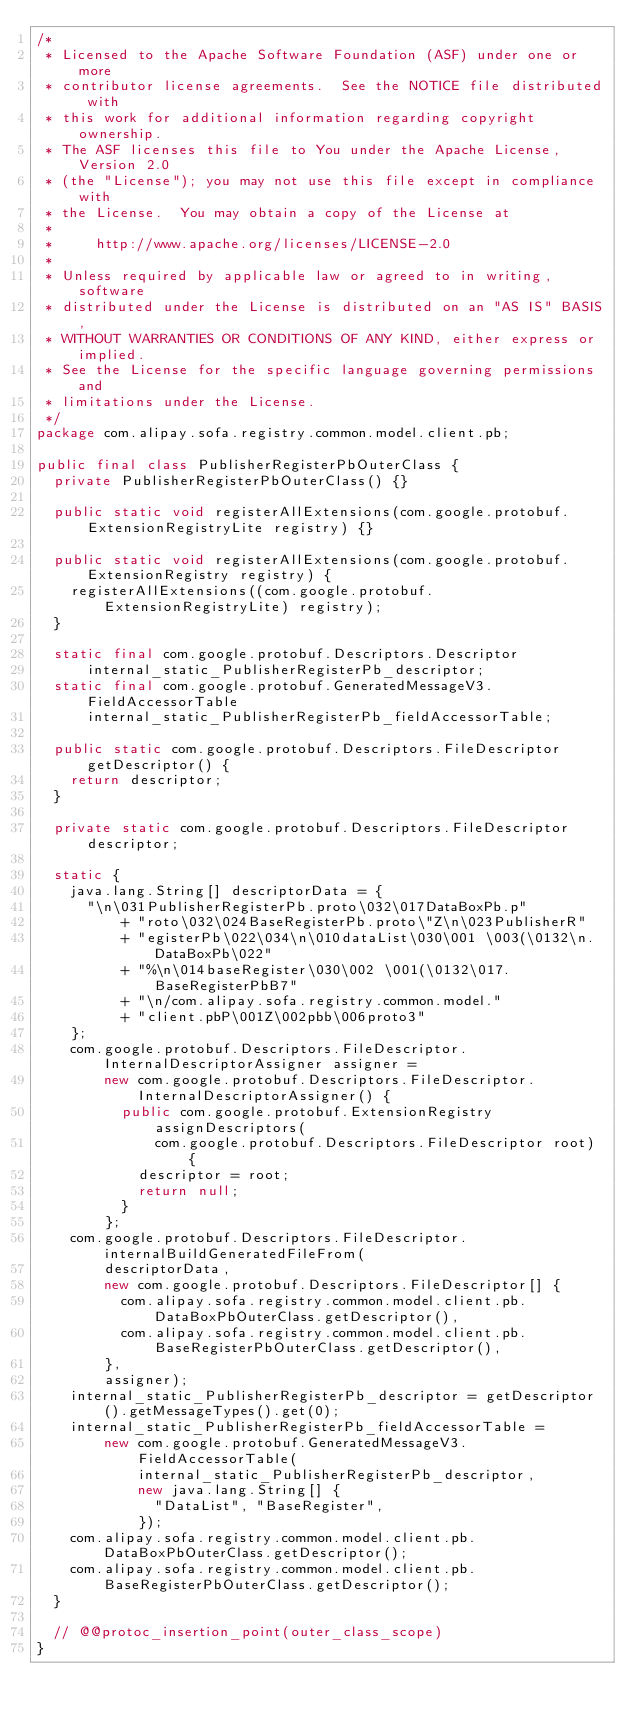<code> <loc_0><loc_0><loc_500><loc_500><_Java_>/*
 * Licensed to the Apache Software Foundation (ASF) under one or more
 * contributor license agreements.  See the NOTICE file distributed with
 * this work for additional information regarding copyright ownership.
 * The ASF licenses this file to You under the Apache License, Version 2.0
 * (the "License"); you may not use this file except in compliance with
 * the License.  You may obtain a copy of the License at
 *
 *     http://www.apache.org/licenses/LICENSE-2.0
 *
 * Unless required by applicable law or agreed to in writing, software
 * distributed under the License is distributed on an "AS IS" BASIS,
 * WITHOUT WARRANTIES OR CONDITIONS OF ANY KIND, either express or implied.
 * See the License for the specific language governing permissions and
 * limitations under the License.
 */
package com.alipay.sofa.registry.common.model.client.pb;

public final class PublisherRegisterPbOuterClass {
  private PublisherRegisterPbOuterClass() {}

  public static void registerAllExtensions(com.google.protobuf.ExtensionRegistryLite registry) {}

  public static void registerAllExtensions(com.google.protobuf.ExtensionRegistry registry) {
    registerAllExtensions((com.google.protobuf.ExtensionRegistryLite) registry);
  }

  static final com.google.protobuf.Descriptors.Descriptor
      internal_static_PublisherRegisterPb_descriptor;
  static final com.google.protobuf.GeneratedMessageV3.FieldAccessorTable
      internal_static_PublisherRegisterPb_fieldAccessorTable;

  public static com.google.protobuf.Descriptors.FileDescriptor getDescriptor() {
    return descriptor;
  }

  private static com.google.protobuf.Descriptors.FileDescriptor descriptor;

  static {
    java.lang.String[] descriptorData = {
      "\n\031PublisherRegisterPb.proto\032\017DataBoxPb.p"
          + "roto\032\024BaseRegisterPb.proto\"Z\n\023PublisherR"
          + "egisterPb\022\034\n\010dataList\030\001 \003(\0132\n.DataBoxPb\022"
          + "%\n\014baseRegister\030\002 \001(\0132\017.BaseRegisterPbB7"
          + "\n/com.alipay.sofa.registry.common.model."
          + "client.pbP\001Z\002pbb\006proto3"
    };
    com.google.protobuf.Descriptors.FileDescriptor.InternalDescriptorAssigner assigner =
        new com.google.protobuf.Descriptors.FileDescriptor.InternalDescriptorAssigner() {
          public com.google.protobuf.ExtensionRegistry assignDescriptors(
              com.google.protobuf.Descriptors.FileDescriptor root) {
            descriptor = root;
            return null;
          }
        };
    com.google.protobuf.Descriptors.FileDescriptor.internalBuildGeneratedFileFrom(
        descriptorData,
        new com.google.protobuf.Descriptors.FileDescriptor[] {
          com.alipay.sofa.registry.common.model.client.pb.DataBoxPbOuterClass.getDescriptor(),
          com.alipay.sofa.registry.common.model.client.pb.BaseRegisterPbOuterClass.getDescriptor(),
        },
        assigner);
    internal_static_PublisherRegisterPb_descriptor = getDescriptor().getMessageTypes().get(0);
    internal_static_PublisherRegisterPb_fieldAccessorTable =
        new com.google.protobuf.GeneratedMessageV3.FieldAccessorTable(
            internal_static_PublisherRegisterPb_descriptor,
            new java.lang.String[] {
              "DataList", "BaseRegister",
            });
    com.alipay.sofa.registry.common.model.client.pb.DataBoxPbOuterClass.getDescriptor();
    com.alipay.sofa.registry.common.model.client.pb.BaseRegisterPbOuterClass.getDescriptor();
  }

  // @@protoc_insertion_point(outer_class_scope)
}
</code> 